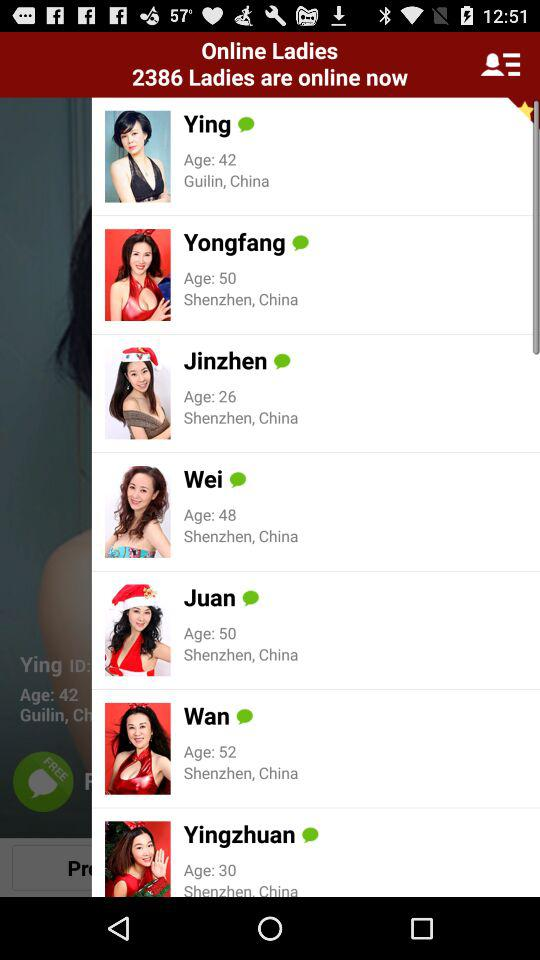What is the name of the person whose age is 50 years? The names of the persons are Yongfang and Juan. 